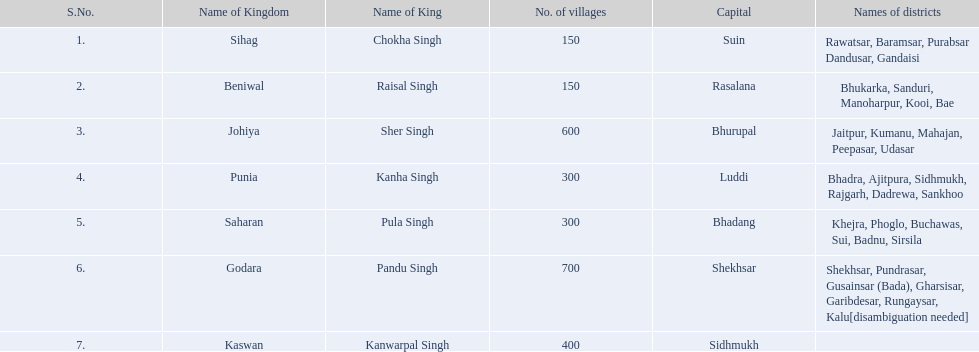Parse the table in full. {'header': ['S.No.', 'Name of Kingdom', 'Name of King', 'No. of villages', 'Capital', 'Names of districts'], 'rows': [['1.', 'Sihag', 'Chokha Singh', '150', 'Suin', 'Rawatsar, Baramsar, Purabsar Dandusar, Gandaisi'], ['2.', 'Beniwal', 'Raisal Singh', '150', 'Rasalana', 'Bhukarka, Sanduri, Manoharpur, Kooi, Bae'], ['3.', 'Johiya', 'Sher Singh', '600', 'Bhurupal', 'Jaitpur, Kumanu, Mahajan, Peepasar, Udasar'], ['4.', 'Punia', 'Kanha Singh', '300', 'Luddi', 'Bhadra, Ajitpura, Sidhmukh, Rajgarh, Dadrewa, Sankhoo'], ['5.', 'Saharan', 'Pula Singh', '300', 'Bhadang', 'Khejra, Phoglo, Buchawas, Sui, Badnu, Sirsila'], ['6.', 'Godara', 'Pandu Singh', '700', 'Shekhsar', 'Shekhsar, Pundrasar, Gusainsar (Bada), Gharsisar, Garibdesar, Rungaysar, Kalu[disambiguation needed]'], ['7.', 'Kaswan', 'Kanwarpal Singh', '400', 'Sidhmukh', '']]} What was the complete number of districts within the godara state? 7. 